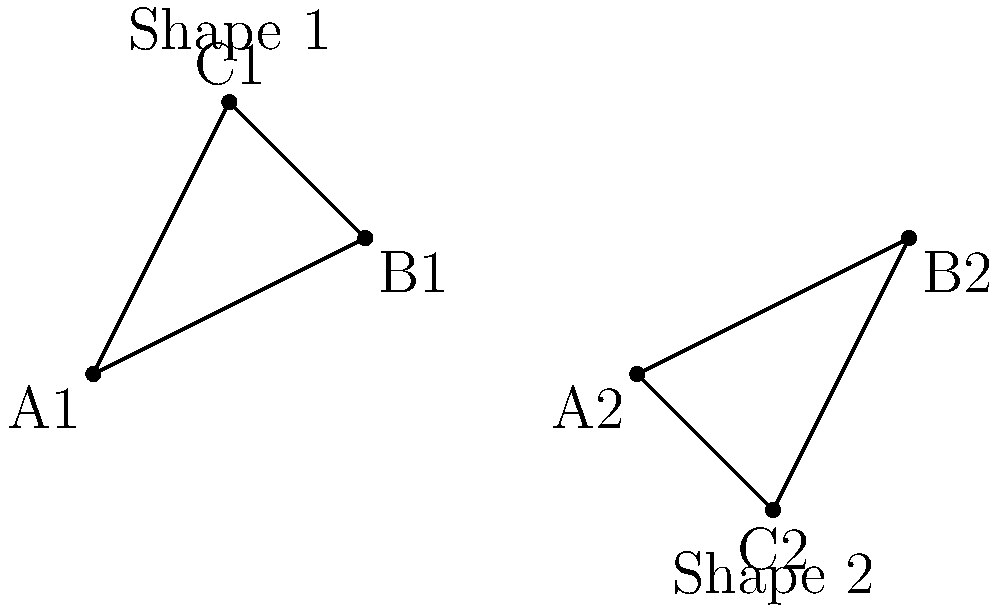As a Siamese cat enthusiast who appreciates realistic portrayals, you're studying simplified representations of cat eye shapes. Two triangular shapes representing Siamese cat eyes are shown above. Are these shapes congruent after reflection and rotation? If so, describe the transformation. If not, explain why. Let's approach this step-by-step:

1) First, we need to check if the triangles have the same side lengths. To do this, we can calculate the distances between the points:

   For Shape 1:
   $A1B1 = \sqrt{2^2 + 1^2} = \sqrt{5}$
   $B1C1 = \sqrt{1^2 + 1^2} = \sqrt{2}$
   $C1A1 = \sqrt{1^2 + 2^2} = \sqrt{5}$

   For Shape 2:
   $A2B2 = \sqrt{2^2 + 1^2} = \sqrt{5}$
   $B2C2 = \sqrt{1^2 + 2^2} = \sqrt{5}$
   $C2A2 = \sqrt{1^2 + 1^2} = \sqrt{2}$

2) We can see that both triangles have side lengths of $\sqrt{5}$, $\sqrt{5}$, and $\sqrt{2}$. This means they are potentially congruent.

3) Next, we need to check if the orientations match. We can see that Shape 2 appears to be a reflection and rotation of Shape 1.

4) To transform Shape 1 into Shape 2:
   a) First, reflect Shape 1 over the y-axis.
   b) Then, rotate the reflected shape 90° clockwise around point A2.

5) After these transformations, Shape 1 would exactly match Shape 2.

Therefore, the shapes are indeed congruent, as they have the same side lengths and can be transformed into each other through reflection and rotation.
Answer: Yes, congruent after reflection over y-axis and 90° clockwise rotation. 